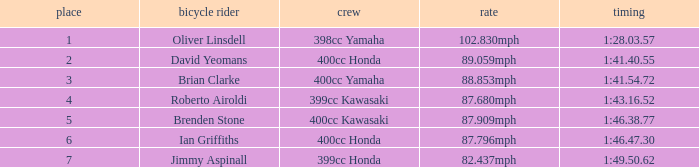What is the rank of the rider with time of 1:41.40.55? 2.0. 